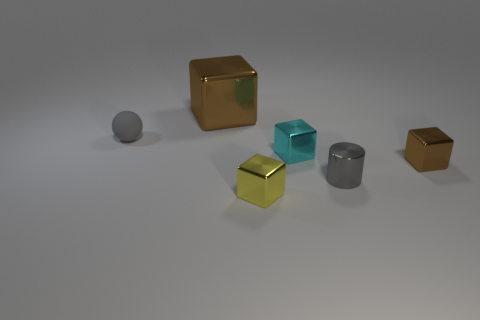Add 1 large brown blocks. How many objects exist? 7 Subtract all spheres. How many objects are left? 5 Subtract all big things. Subtract all yellow metallic blocks. How many objects are left? 4 Add 3 large metallic objects. How many large metallic objects are left? 4 Add 6 gray balls. How many gray balls exist? 7 Subtract 0 red spheres. How many objects are left? 6 